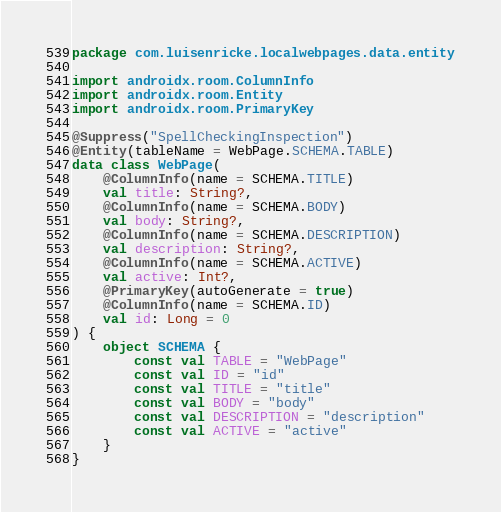Convert code to text. <code><loc_0><loc_0><loc_500><loc_500><_Kotlin_>package com.luisenricke.localwebpages.data.entity

import androidx.room.ColumnInfo
import androidx.room.Entity
import androidx.room.PrimaryKey

@Suppress("SpellCheckingInspection")
@Entity(tableName = WebPage.SCHEMA.TABLE)
data class WebPage(
    @ColumnInfo(name = SCHEMA.TITLE)
    val title: String?,
    @ColumnInfo(name = SCHEMA.BODY)
    val body: String?,
    @ColumnInfo(name = SCHEMA.DESCRIPTION)
    val description: String?,
    @ColumnInfo(name = SCHEMA.ACTIVE)
    val active: Int?,
    @PrimaryKey(autoGenerate = true)
    @ColumnInfo(name = SCHEMA.ID)
    val id: Long = 0
) {
    object SCHEMA {
        const val TABLE = "WebPage"
        const val ID = "id"
        const val TITLE = "title"
        const val BODY = "body"
        const val DESCRIPTION = "description"
        const val ACTIVE = "active"
    }
}</code> 